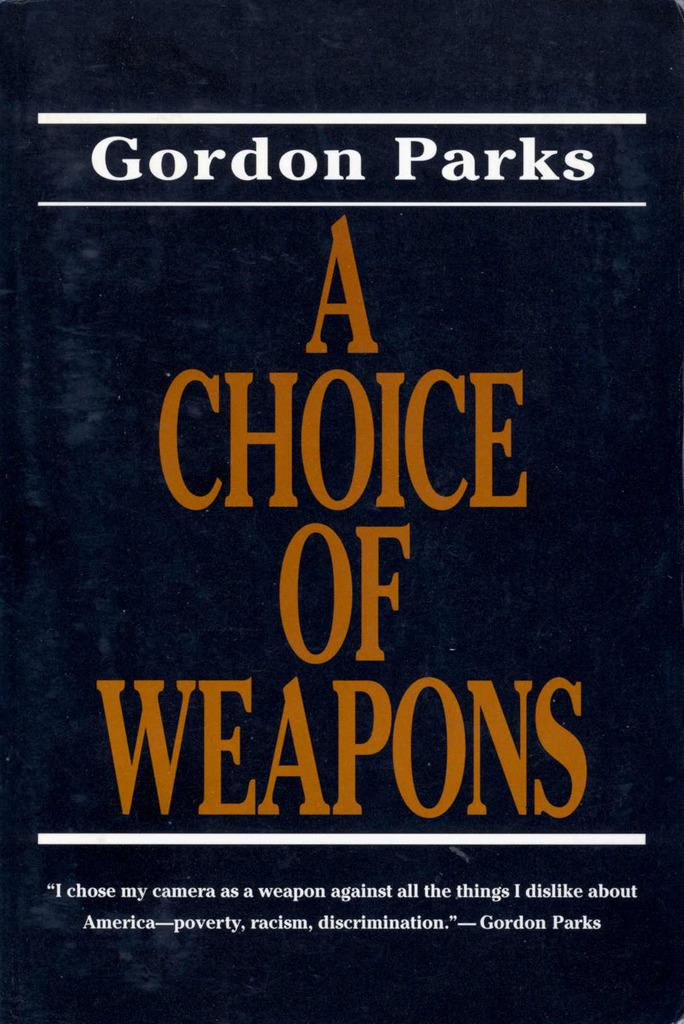<image>
Render a clear and concise summary of the photo. A copy of the book A Choice of Weapons by Gordon Parks. 